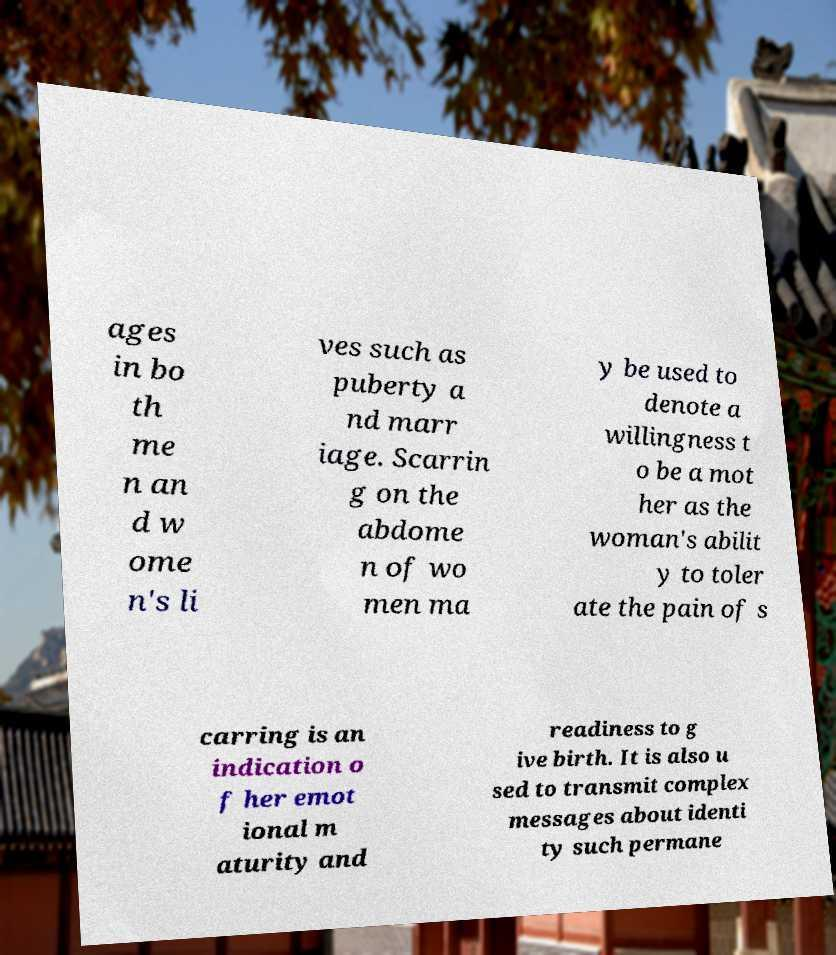What messages or text are displayed in this image? I need them in a readable, typed format. ages in bo th me n an d w ome n's li ves such as puberty a nd marr iage. Scarrin g on the abdome n of wo men ma y be used to denote a willingness t o be a mot her as the woman's abilit y to toler ate the pain of s carring is an indication o f her emot ional m aturity and readiness to g ive birth. It is also u sed to transmit complex messages about identi ty such permane 